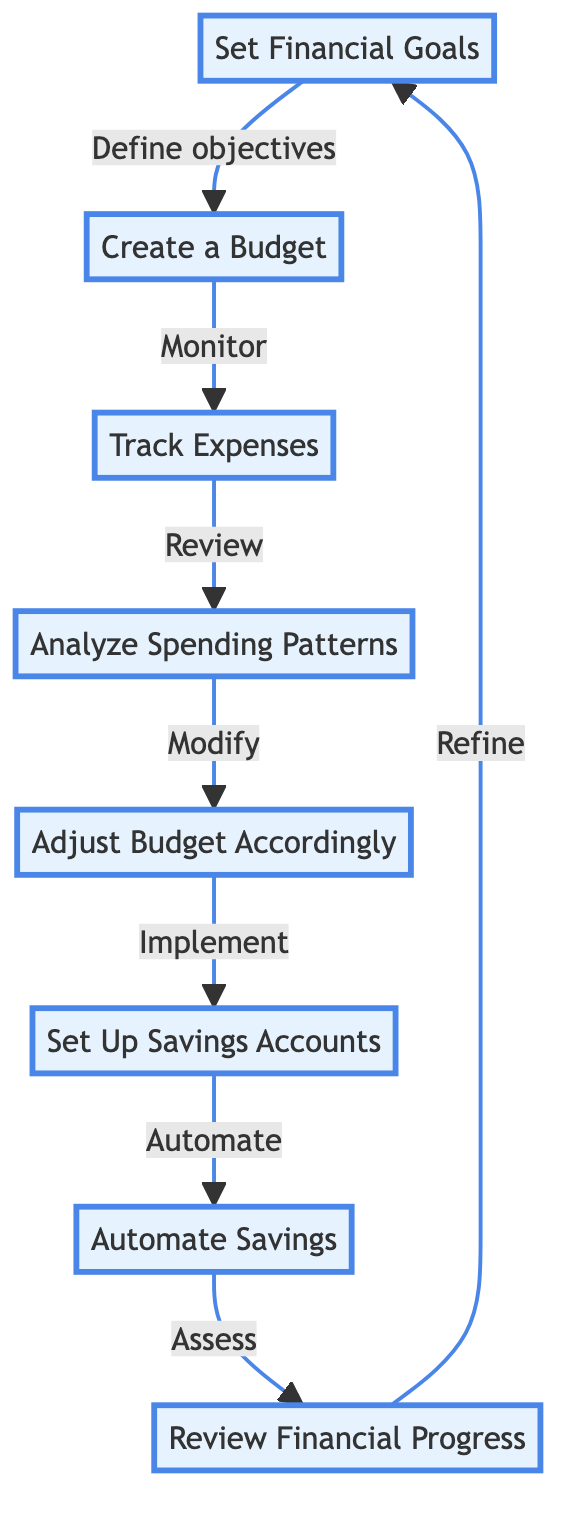What is the first step in the workflow? The diagram starts with the node labeled 'Set Financial Goals', indicating it is the initial step in the workflow.
Answer: Set Financial Goals How many main steps are there in the workflow? By counting the nodes, there are a total of eight main steps represented in the diagram.
Answer: Eight What comes immediately after 'Create a Budget'? The next step indicated after 'Create a Budget' is 'Track Expenses', showing the sequential flow of the process.
Answer: Track Expenses Which process involves monitoring daily spending? The process that focuses on monitoring daily spending is labeled 'Track Expenses', as described in the diagram.
Answer: Track Expenses What is the last step in the workflow? The final step in the workflow is labeled 'Review Financial Progress', marking the end of the sequence.
Answer: Review Financial Progress What is the relationship between 'Analyze Spending Patterns' and 'Adjust Budget Accordingly'? 'Analyze Spending Patterns' leads directly to 'Adjust Budget Accordingly', indicating that analyzing leads to adjusting based on insights gained.
Answer: Modify What type of accounts should be set up for different goals? The process specifies 'Set Up Savings Accounts' for different savings goals, indicating a structured approach to saving.
Answer: Savings Accounts How do you ensure consistent saving? The diagram states to 'Automate Savings' by setting up automatic transfers to secure consistent saving over time.
Answer: Automate Savings 